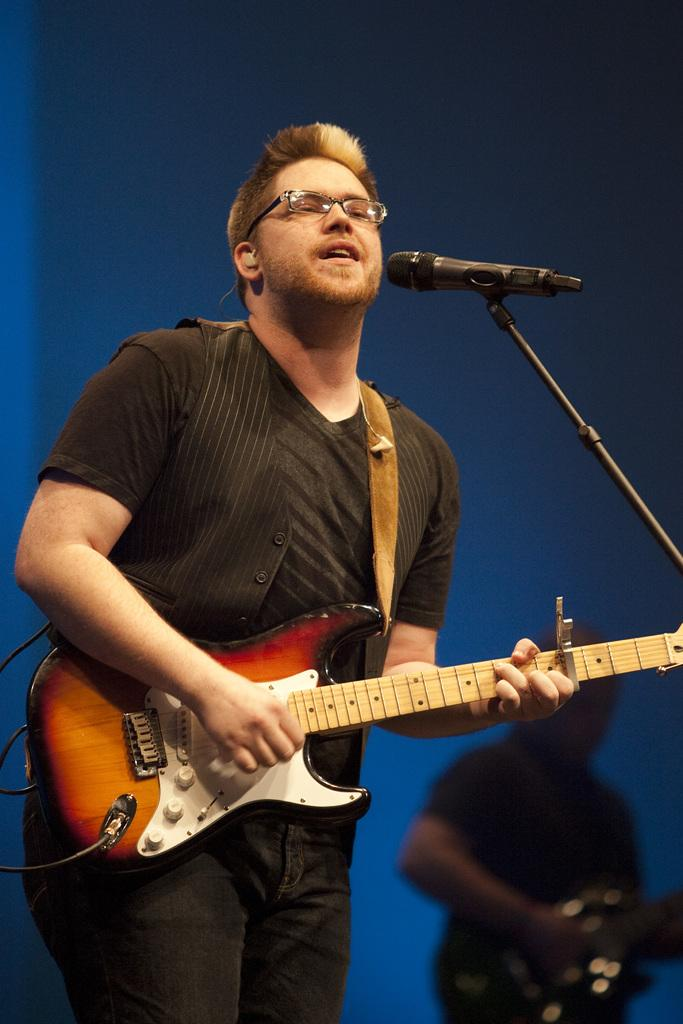What is the main subject of the image? There is a man in the image. What is the man holding in the image? The man is holding a guitar. Can you describe the background of the image? The background of the image is blurred. Is there a group of people joining hands in the image? There is no group of people joining hands in the image; it features a man holding a guitar in a blurred background. 